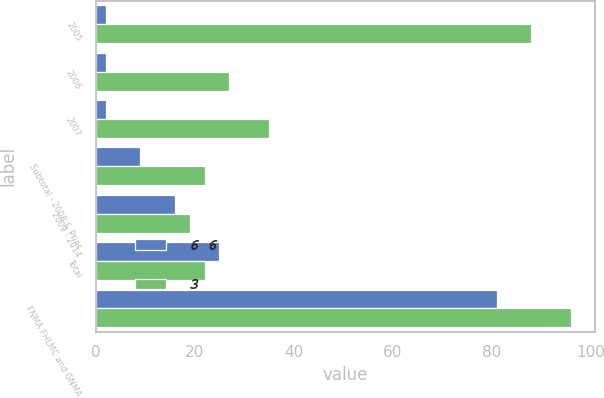Convert chart to OTSL. <chart><loc_0><loc_0><loc_500><loc_500><stacked_bar_chart><ecel><fcel>2005<fcel>2006<fcel>2007<fcel>Subtotal - 2008 & Prior<fcel>2009 - 2014<fcel>Total<fcel>FNMA FHLMC and GNMA<nl><fcel>6 6<fcel>2<fcel>2<fcel>2<fcel>9<fcel>16<fcel>25<fcel>81<nl><fcel>3<fcel>88<fcel>27<fcel>35<fcel>22<fcel>19<fcel>22<fcel>96<nl></chart> 